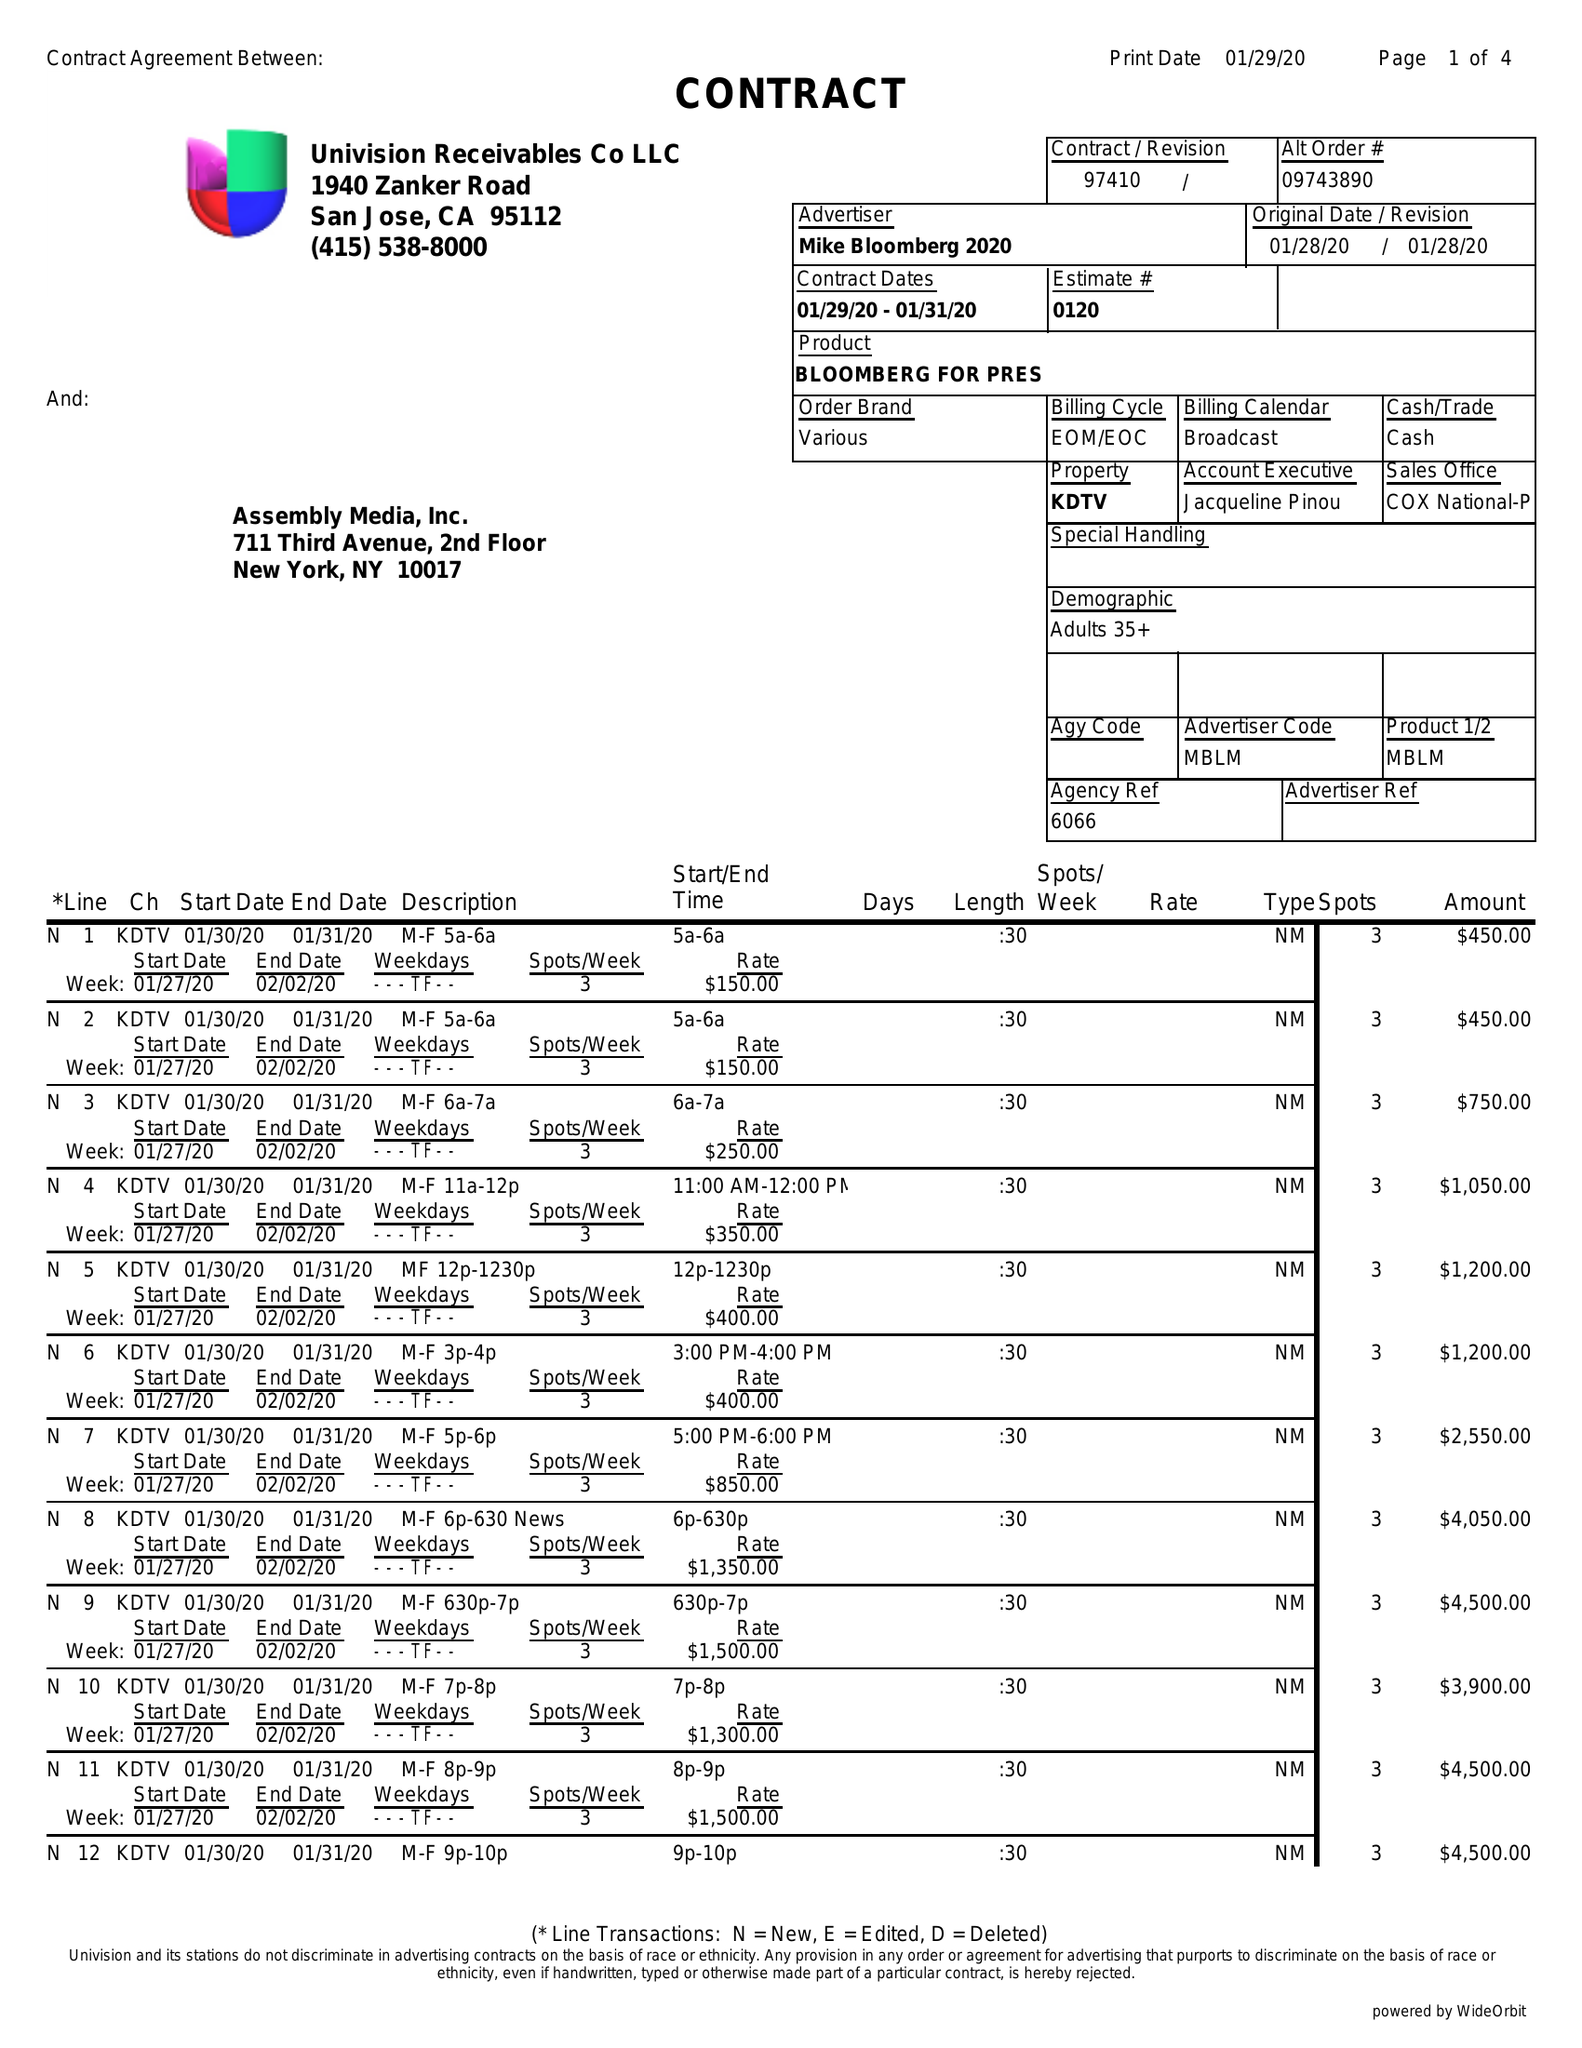What is the value for the advertiser?
Answer the question using a single word or phrase. MIKE BLOOMBERG 2020 